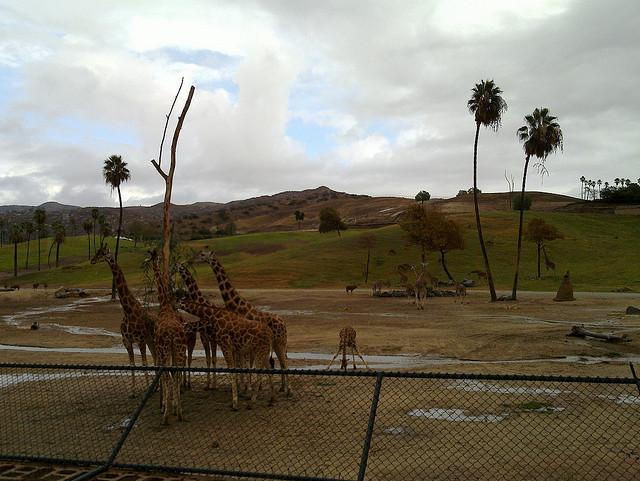What type of enclosure is shown? Please explain your reasoning. fence. One can see the posts and chain links of this type of enclosure. 